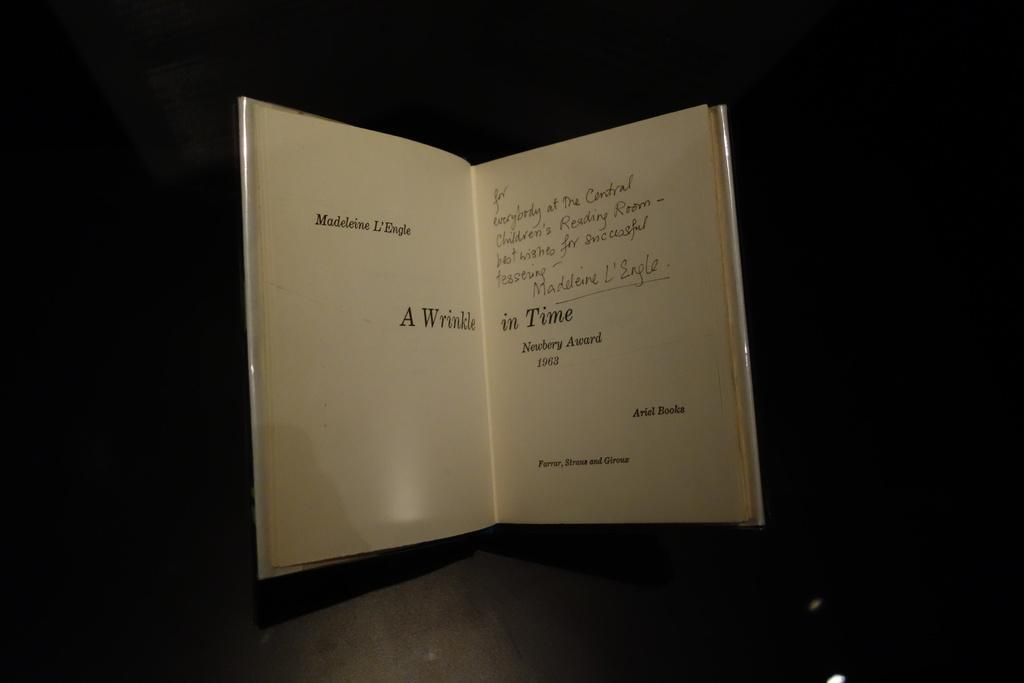<image>
Offer a succinct explanation of the picture presented. The book A Wrinkle in Time is open and waiting to be read. 